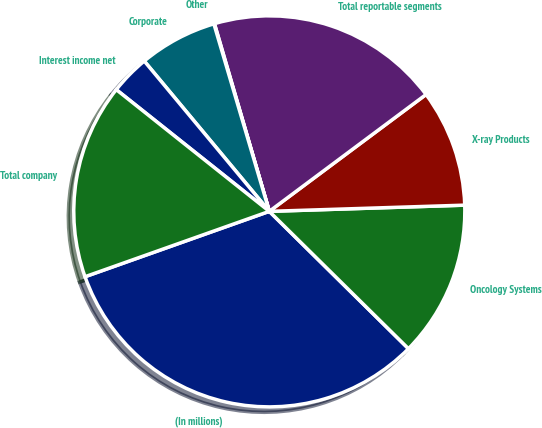Convert chart to OTSL. <chart><loc_0><loc_0><loc_500><loc_500><pie_chart><fcel>(In millions)<fcel>Oncology Systems<fcel>X-ray Products<fcel>Total reportable segments<fcel>Other<fcel>Corporate<fcel>Interest income net<fcel>Total company<nl><fcel>32.18%<fcel>12.9%<fcel>9.69%<fcel>19.33%<fcel>0.05%<fcel>6.47%<fcel>3.26%<fcel>16.12%<nl></chart> 